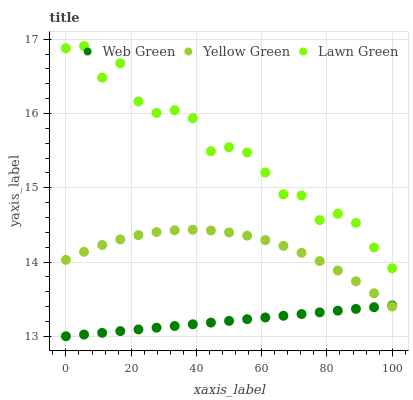Does Web Green have the minimum area under the curve?
Answer yes or no. Yes. Does Lawn Green have the maximum area under the curve?
Answer yes or no. Yes. Does Yellow Green have the minimum area under the curve?
Answer yes or no. No. Does Yellow Green have the maximum area under the curve?
Answer yes or no. No. Is Web Green the smoothest?
Answer yes or no. Yes. Is Lawn Green the roughest?
Answer yes or no. Yes. Is Yellow Green the smoothest?
Answer yes or no. No. Is Yellow Green the roughest?
Answer yes or no. No. Does Web Green have the lowest value?
Answer yes or no. Yes. Does Yellow Green have the lowest value?
Answer yes or no. No. Does Lawn Green have the highest value?
Answer yes or no. Yes. Does Yellow Green have the highest value?
Answer yes or no. No. Is Web Green less than Lawn Green?
Answer yes or no. Yes. Is Lawn Green greater than Web Green?
Answer yes or no. Yes. Does Web Green intersect Yellow Green?
Answer yes or no. Yes. Is Web Green less than Yellow Green?
Answer yes or no. No. Is Web Green greater than Yellow Green?
Answer yes or no. No. Does Web Green intersect Lawn Green?
Answer yes or no. No. 